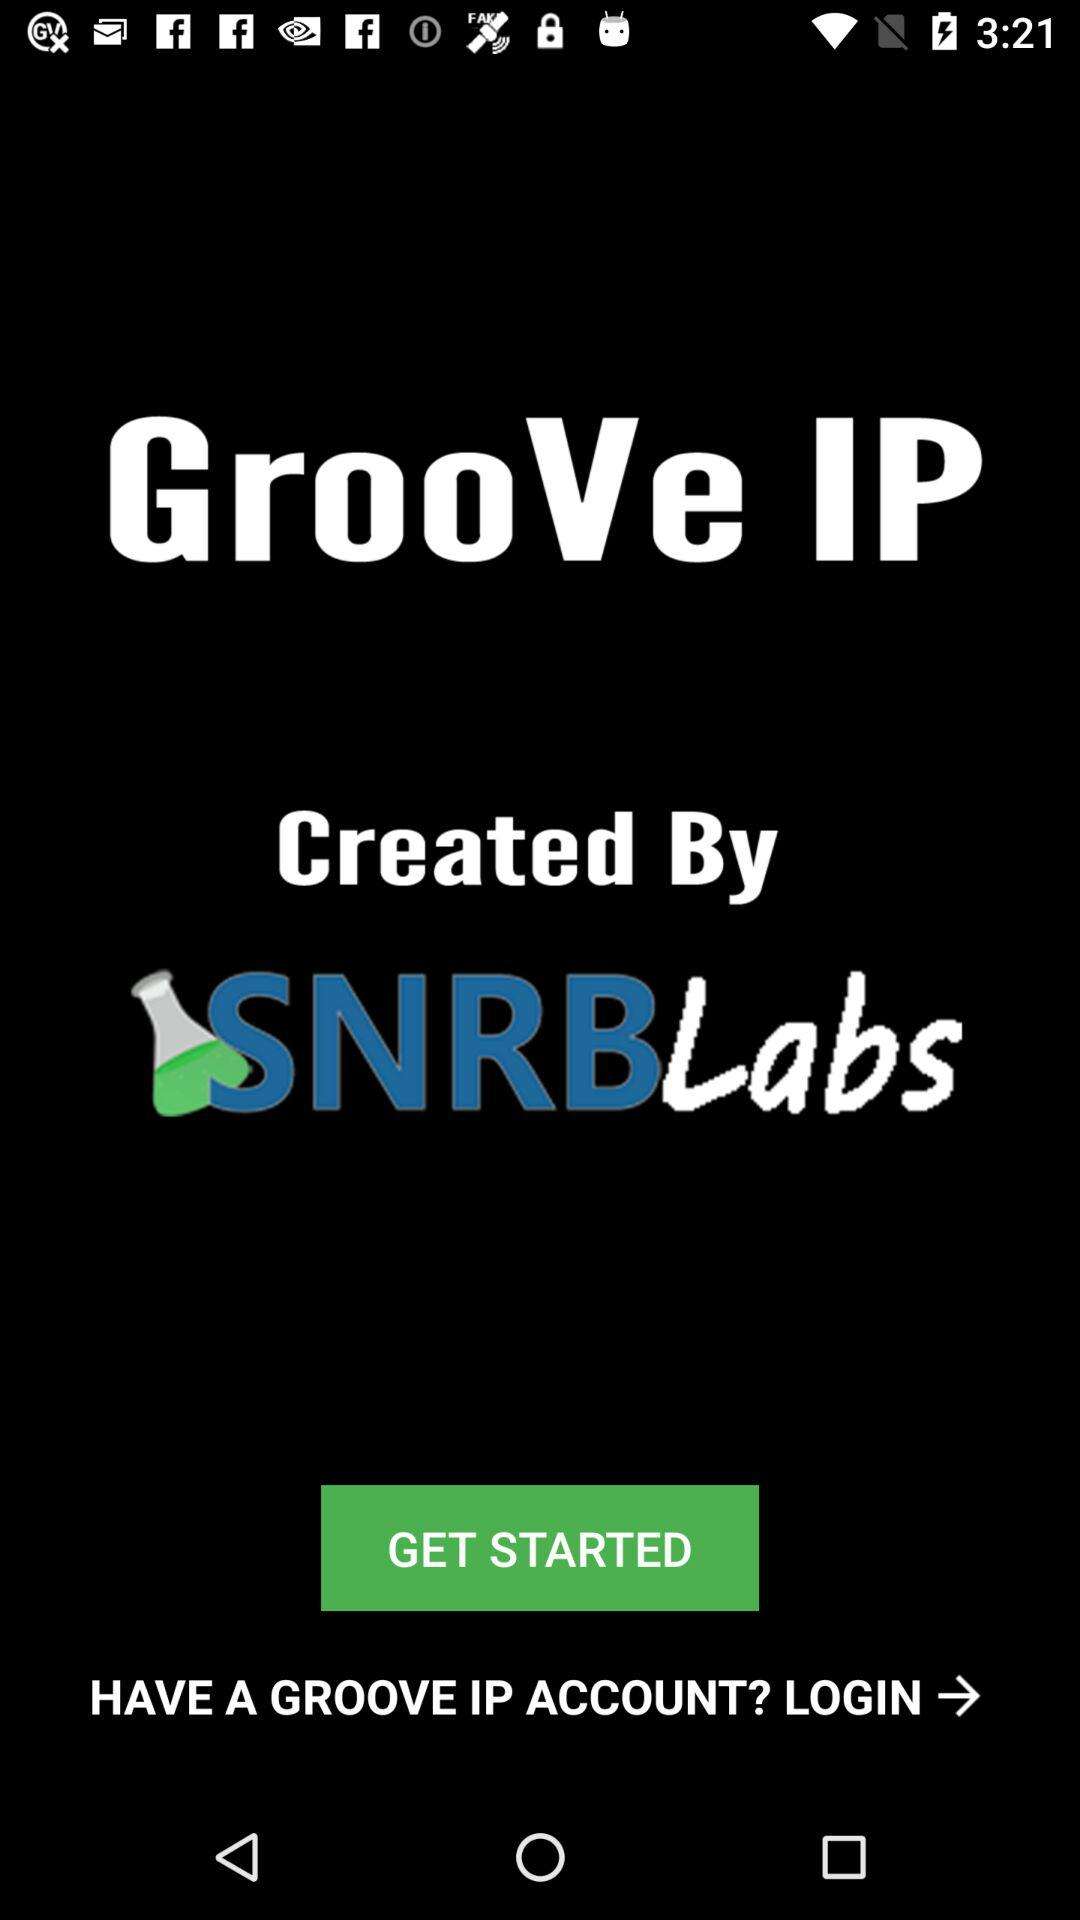What is the name of the application? The name of the application is "GrooVe IP". 